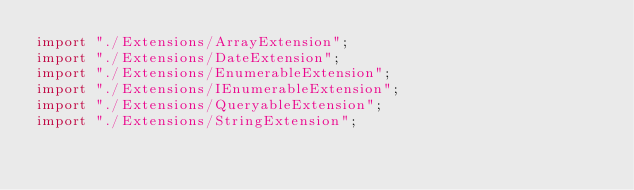Convert code to text. <code><loc_0><loc_0><loc_500><loc_500><_TypeScript_>import "./Extensions/ArrayExtension";
import "./Extensions/DateExtension";
import "./Extensions/EnumerableExtension";
import "./Extensions/IEnumerableExtension";
import "./Extensions/QueryableExtension";
import "./Extensions/StringExtension";
</code> 